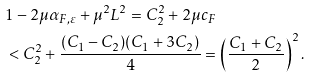Convert formula to latex. <formula><loc_0><loc_0><loc_500><loc_500>& 1 - 2 \mu \alpha _ { F , \varepsilon } + \mu ^ { 2 } L ^ { 2 } = C _ { 2 } ^ { 2 } + 2 \mu c _ { F } \\ & < C _ { 2 } ^ { 2 } + \frac { ( C _ { 1 } - C _ { 2 } ) ( C _ { 1 } + 3 C _ { 2 } ) } { 4 } = \left ( \frac { C _ { 1 } + C _ { 2 } } { 2 } \right ) ^ { 2 } .</formula> 